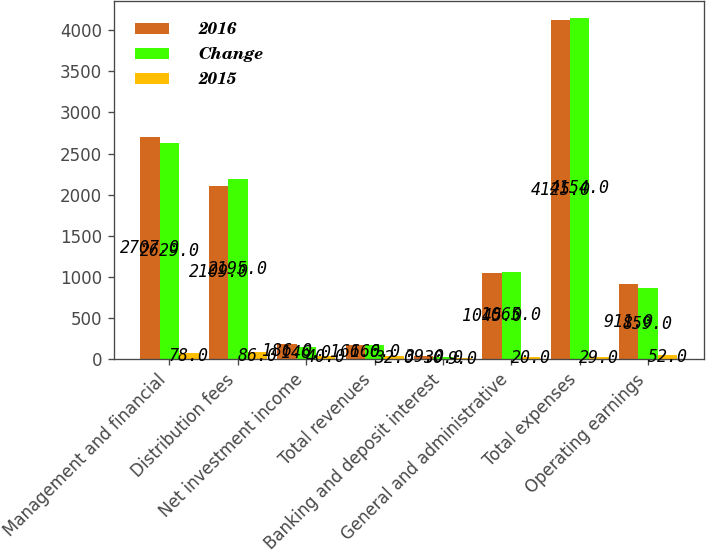Convert chart to OTSL. <chart><loc_0><loc_0><loc_500><loc_500><stacked_bar_chart><ecel><fcel>Management and financial<fcel>Distribution fees<fcel>Net investment income<fcel>Total revenues<fcel>Banking and deposit interest<fcel>General and administrative<fcel>Total expenses<fcel>Operating earnings<nl><fcel>2016<fcel>2707<fcel>2109<fcel>186<fcel>166<fcel>39<fcel>1045<fcel>4125<fcel>911<nl><fcel>Change<fcel>2629<fcel>2195<fcel>146<fcel>166<fcel>30<fcel>1065<fcel>4154<fcel>859<nl><fcel>2015<fcel>78<fcel>86<fcel>40<fcel>32<fcel>9<fcel>20<fcel>29<fcel>52<nl></chart> 